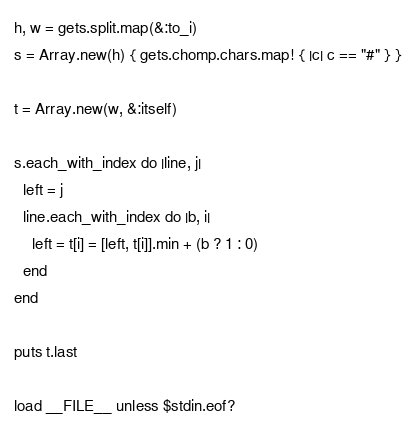Convert code to text. <code><loc_0><loc_0><loc_500><loc_500><_Ruby_>h, w = gets.split.map(&:to_i)
s = Array.new(h) { gets.chomp.chars.map! { |c| c == "#" } }

t = Array.new(w, &:itself)

s.each_with_index do |line, j|
  left = j
  line.each_with_index do |b, i|
    left = t[i] = [left, t[i]].min + (b ? 1 : 0)
  end
end

puts t.last

load __FILE__ unless $stdin.eof?
</code> 